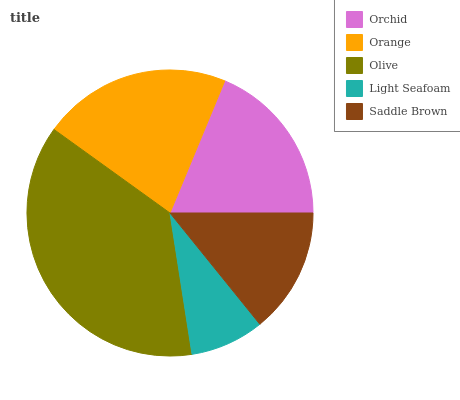Is Light Seafoam the minimum?
Answer yes or no. Yes. Is Olive the maximum?
Answer yes or no. Yes. Is Orange the minimum?
Answer yes or no. No. Is Orange the maximum?
Answer yes or no. No. Is Orange greater than Orchid?
Answer yes or no. Yes. Is Orchid less than Orange?
Answer yes or no. Yes. Is Orchid greater than Orange?
Answer yes or no. No. Is Orange less than Orchid?
Answer yes or no. No. Is Orchid the high median?
Answer yes or no. Yes. Is Orchid the low median?
Answer yes or no. Yes. Is Olive the high median?
Answer yes or no. No. Is Saddle Brown the low median?
Answer yes or no. No. 